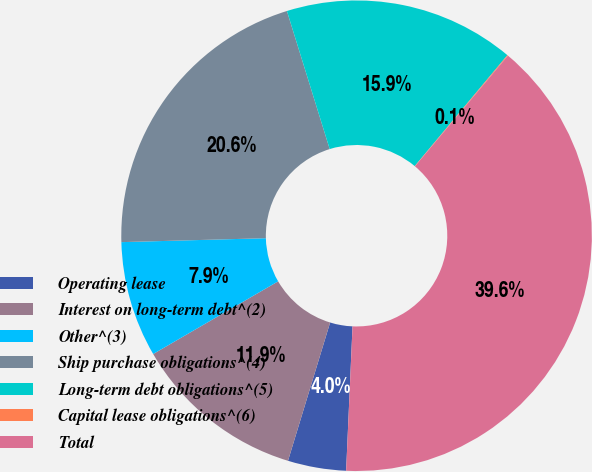Convert chart to OTSL. <chart><loc_0><loc_0><loc_500><loc_500><pie_chart><fcel>Operating lease<fcel>Interest on long-term debt^(2)<fcel>Other^(3)<fcel>Ship purchase obligations^(4)<fcel>Long-term debt obligations^(5)<fcel>Capital lease obligations^(6)<fcel>Total<nl><fcel>4.0%<fcel>11.91%<fcel>7.95%<fcel>20.65%<fcel>15.86%<fcel>0.05%<fcel>39.58%<nl></chart> 